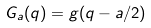Convert formula to latex. <formula><loc_0><loc_0><loc_500><loc_500>G _ { a } ( q ) = g ( q - a / 2 )</formula> 